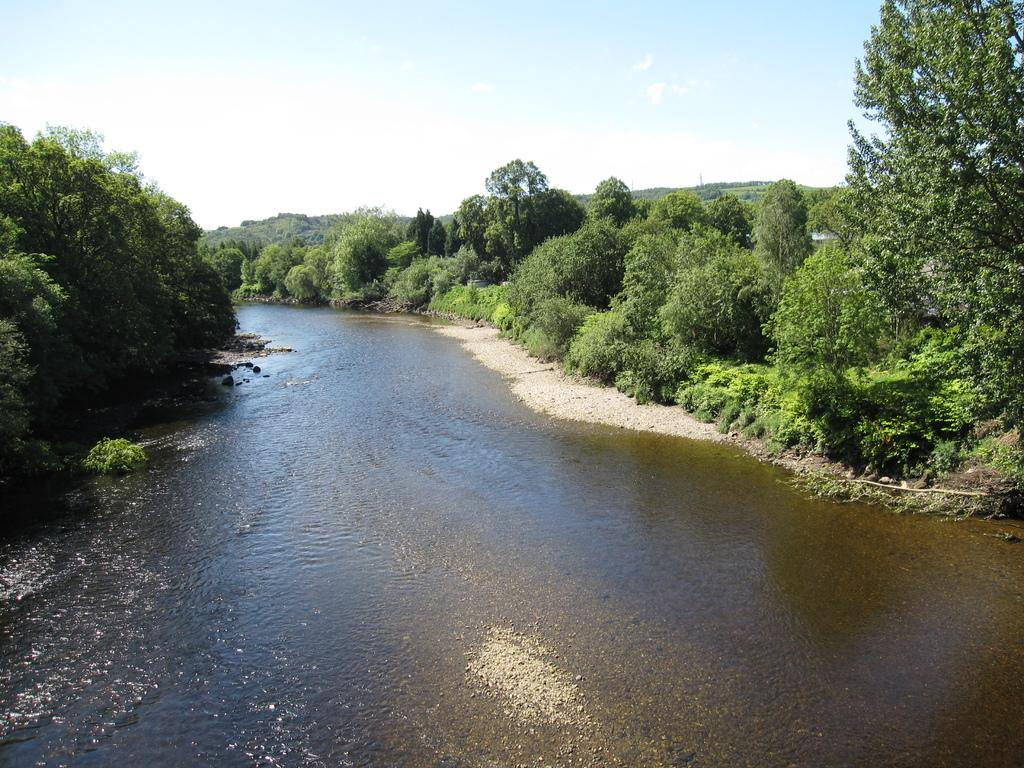What type of natural feature is present in the image? There is a river in the image. What can be seen on the sides of the river? There are trees on the sides of the river. What is visible in the background of the image? The sky is visible in the background of the image. What type of eggs can be seen on the top of the river in the image? There are no eggs present in the image, and the river does not have a top. 